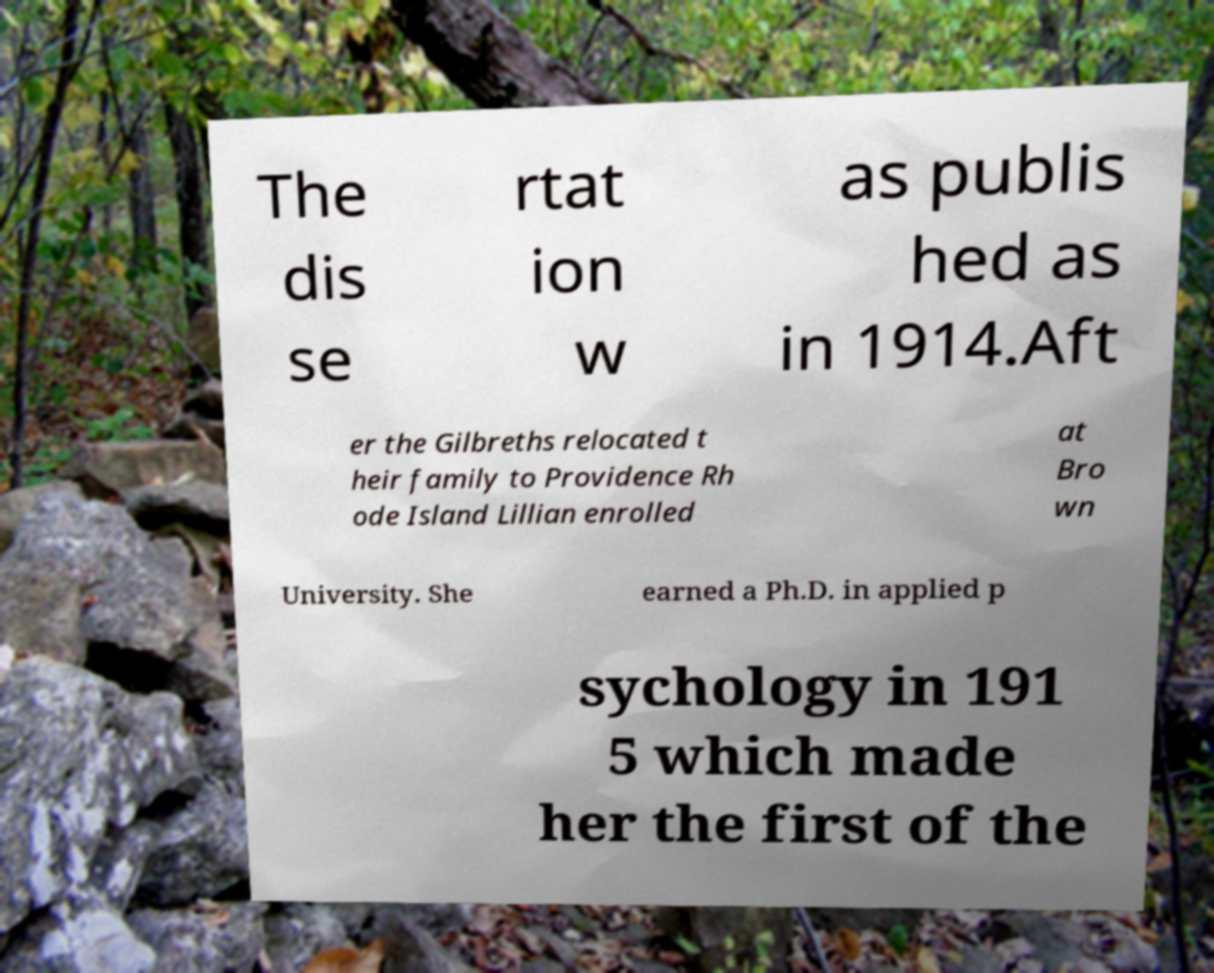What messages or text are displayed in this image? I need them in a readable, typed format. The dis se rtat ion w as publis hed as in 1914.Aft er the Gilbreths relocated t heir family to Providence Rh ode Island Lillian enrolled at Bro wn University. She earned a Ph.D. in applied p sychology in 191 5 which made her the first of the 